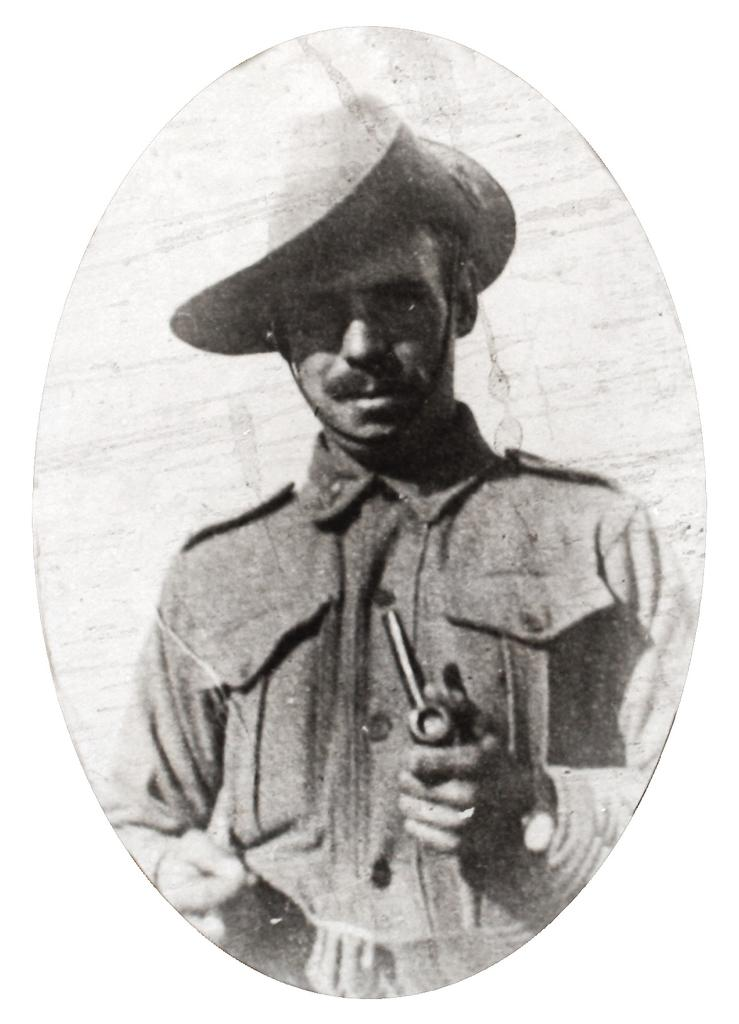What can be seen in the image? There is a person in the image. Can you describe the person's attire? The person is wearing a cap. What is the person holding in the image? The person is holding something. What is the color scheme of the image? The image is in black and white. Can you hear the person crying in the image? The image is a still photograph, so there is no sound or indication of crying. What type of sock is the person wearing in the image? There is no sock visible in the image. 